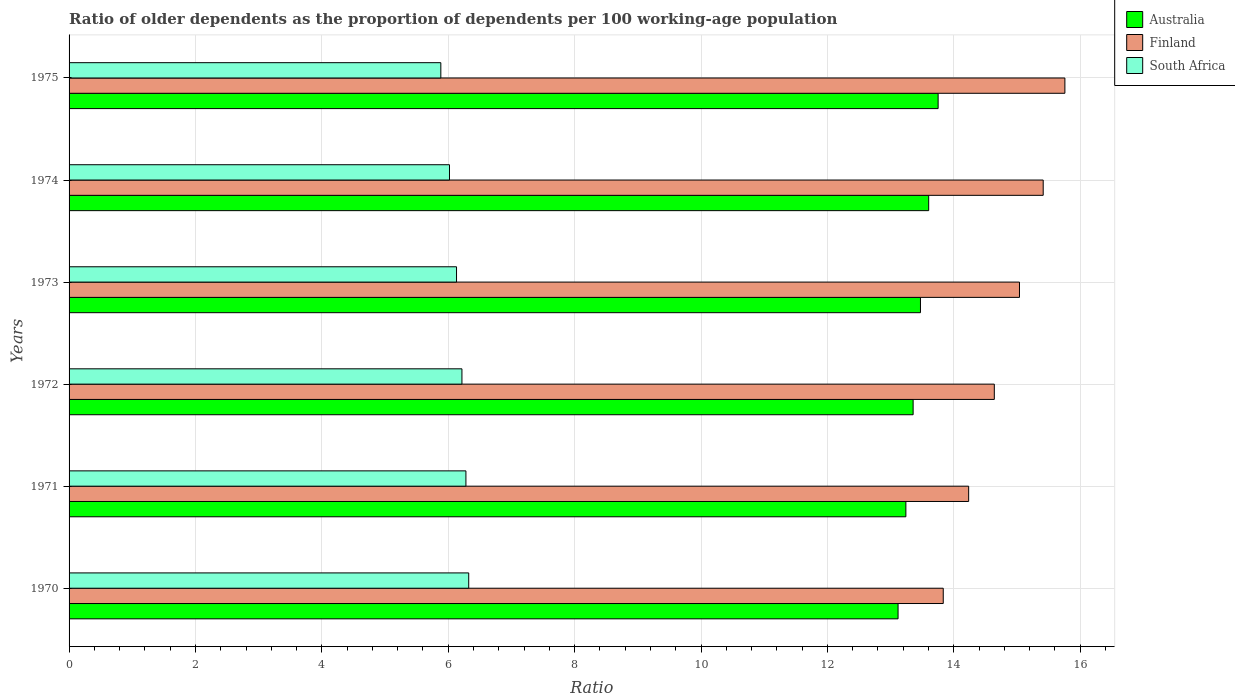How many groups of bars are there?
Provide a succinct answer. 6. Are the number of bars per tick equal to the number of legend labels?
Offer a very short reply. Yes. How many bars are there on the 3rd tick from the top?
Provide a succinct answer. 3. What is the label of the 6th group of bars from the top?
Provide a short and direct response. 1970. In how many cases, is the number of bars for a given year not equal to the number of legend labels?
Your response must be concise. 0. What is the age dependency ratio(old) in Finland in 1972?
Your answer should be very brief. 14.64. Across all years, what is the maximum age dependency ratio(old) in Finland?
Your answer should be compact. 15.76. Across all years, what is the minimum age dependency ratio(old) in Australia?
Offer a terse response. 13.12. In which year was the age dependency ratio(old) in Australia maximum?
Give a very brief answer. 1975. What is the total age dependency ratio(old) in Australia in the graph?
Make the answer very short. 80.54. What is the difference between the age dependency ratio(old) in Finland in 1970 and that in 1971?
Offer a terse response. -0.4. What is the difference between the age dependency ratio(old) in Finland in 1970 and the age dependency ratio(old) in Australia in 1974?
Ensure brevity in your answer.  0.23. What is the average age dependency ratio(old) in Australia per year?
Provide a short and direct response. 13.42. In the year 1973, what is the difference between the age dependency ratio(old) in Australia and age dependency ratio(old) in South Africa?
Provide a short and direct response. 7.34. In how many years, is the age dependency ratio(old) in Australia greater than 13.2 ?
Provide a short and direct response. 5. What is the ratio of the age dependency ratio(old) in Finland in 1970 to that in 1975?
Provide a succinct answer. 0.88. Is the difference between the age dependency ratio(old) in Australia in 1972 and 1973 greater than the difference between the age dependency ratio(old) in South Africa in 1972 and 1973?
Offer a very short reply. No. What is the difference between the highest and the second highest age dependency ratio(old) in South Africa?
Give a very brief answer. 0.04. What is the difference between the highest and the lowest age dependency ratio(old) in South Africa?
Provide a short and direct response. 0.44. In how many years, is the age dependency ratio(old) in South Africa greater than the average age dependency ratio(old) in South Africa taken over all years?
Ensure brevity in your answer.  3. What does the 3rd bar from the bottom in 1974 represents?
Provide a succinct answer. South Africa. Is it the case that in every year, the sum of the age dependency ratio(old) in South Africa and age dependency ratio(old) in Australia is greater than the age dependency ratio(old) in Finland?
Provide a short and direct response. Yes. Are the values on the major ticks of X-axis written in scientific E-notation?
Give a very brief answer. No. Does the graph contain any zero values?
Make the answer very short. No. Where does the legend appear in the graph?
Your answer should be very brief. Top right. What is the title of the graph?
Offer a very short reply. Ratio of older dependents as the proportion of dependents per 100 working-age population. What is the label or title of the X-axis?
Make the answer very short. Ratio. What is the Ratio of Australia in 1970?
Your answer should be very brief. 13.12. What is the Ratio of Finland in 1970?
Offer a terse response. 13.83. What is the Ratio in South Africa in 1970?
Your answer should be compact. 6.32. What is the Ratio of Australia in 1971?
Ensure brevity in your answer.  13.24. What is the Ratio of Finland in 1971?
Offer a terse response. 14.23. What is the Ratio in South Africa in 1971?
Offer a terse response. 6.28. What is the Ratio in Australia in 1972?
Give a very brief answer. 13.36. What is the Ratio in Finland in 1972?
Provide a short and direct response. 14.64. What is the Ratio of South Africa in 1972?
Your answer should be compact. 6.22. What is the Ratio in Australia in 1973?
Offer a terse response. 13.47. What is the Ratio in Finland in 1973?
Offer a very short reply. 15.04. What is the Ratio of South Africa in 1973?
Your answer should be very brief. 6.13. What is the Ratio in Australia in 1974?
Your answer should be very brief. 13.6. What is the Ratio of Finland in 1974?
Ensure brevity in your answer.  15.41. What is the Ratio in South Africa in 1974?
Offer a very short reply. 6.02. What is the Ratio of Australia in 1975?
Ensure brevity in your answer.  13.75. What is the Ratio of Finland in 1975?
Give a very brief answer. 15.76. What is the Ratio in South Africa in 1975?
Offer a very short reply. 5.88. Across all years, what is the maximum Ratio of Australia?
Your answer should be compact. 13.75. Across all years, what is the maximum Ratio in Finland?
Make the answer very short. 15.76. Across all years, what is the maximum Ratio of South Africa?
Provide a short and direct response. 6.32. Across all years, what is the minimum Ratio in Australia?
Ensure brevity in your answer.  13.12. Across all years, what is the minimum Ratio of Finland?
Offer a terse response. 13.83. Across all years, what is the minimum Ratio in South Africa?
Your answer should be compact. 5.88. What is the total Ratio of Australia in the graph?
Your answer should be compact. 80.54. What is the total Ratio in Finland in the graph?
Ensure brevity in your answer.  88.92. What is the total Ratio in South Africa in the graph?
Your answer should be very brief. 36.85. What is the difference between the Ratio of Australia in 1970 and that in 1971?
Give a very brief answer. -0.12. What is the difference between the Ratio of Finland in 1970 and that in 1971?
Provide a short and direct response. -0.4. What is the difference between the Ratio in South Africa in 1970 and that in 1971?
Provide a short and direct response. 0.04. What is the difference between the Ratio in Australia in 1970 and that in 1972?
Give a very brief answer. -0.24. What is the difference between the Ratio in Finland in 1970 and that in 1972?
Give a very brief answer. -0.81. What is the difference between the Ratio in South Africa in 1970 and that in 1972?
Offer a very short reply. 0.11. What is the difference between the Ratio in Australia in 1970 and that in 1973?
Ensure brevity in your answer.  -0.35. What is the difference between the Ratio in Finland in 1970 and that in 1973?
Give a very brief answer. -1.21. What is the difference between the Ratio in South Africa in 1970 and that in 1973?
Give a very brief answer. 0.19. What is the difference between the Ratio of Australia in 1970 and that in 1974?
Provide a short and direct response. -0.48. What is the difference between the Ratio of Finland in 1970 and that in 1974?
Your answer should be very brief. -1.58. What is the difference between the Ratio in South Africa in 1970 and that in 1974?
Provide a short and direct response. 0.3. What is the difference between the Ratio of Australia in 1970 and that in 1975?
Make the answer very short. -0.63. What is the difference between the Ratio in Finland in 1970 and that in 1975?
Offer a terse response. -1.92. What is the difference between the Ratio in South Africa in 1970 and that in 1975?
Offer a terse response. 0.44. What is the difference between the Ratio in Australia in 1971 and that in 1972?
Make the answer very short. -0.11. What is the difference between the Ratio of Finland in 1971 and that in 1972?
Keep it short and to the point. -0.41. What is the difference between the Ratio of South Africa in 1971 and that in 1972?
Keep it short and to the point. 0.06. What is the difference between the Ratio of Australia in 1971 and that in 1973?
Make the answer very short. -0.23. What is the difference between the Ratio of Finland in 1971 and that in 1973?
Offer a very short reply. -0.8. What is the difference between the Ratio in South Africa in 1971 and that in 1973?
Your answer should be very brief. 0.15. What is the difference between the Ratio of Australia in 1971 and that in 1974?
Offer a very short reply. -0.36. What is the difference between the Ratio of Finland in 1971 and that in 1974?
Your response must be concise. -1.18. What is the difference between the Ratio in South Africa in 1971 and that in 1974?
Your answer should be compact. 0.26. What is the difference between the Ratio in Australia in 1971 and that in 1975?
Your answer should be compact. -0.51. What is the difference between the Ratio in Finland in 1971 and that in 1975?
Your answer should be very brief. -1.52. What is the difference between the Ratio of South Africa in 1971 and that in 1975?
Provide a short and direct response. 0.4. What is the difference between the Ratio of Australia in 1972 and that in 1973?
Offer a very short reply. -0.12. What is the difference between the Ratio of Finland in 1972 and that in 1973?
Keep it short and to the point. -0.4. What is the difference between the Ratio in South Africa in 1972 and that in 1973?
Your answer should be very brief. 0.09. What is the difference between the Ratio of Australia in 1972 and that in 1974?
Make the answer very short. -0.25. What is the difference between the Ratio of Finland in 1972 and that in 1974?
Your answer should be very brief. -0.77. What is the difference between the Ratio in South Africa in 1972 and that in 1974?
Offer a very short reply. 0.2. What is the difference between the Ratio of Australia in 1972 and that in 1975?
Your answer should be very brief. -0.4. What is the difference between the Ratio in Finland in 1972 and that in 1975?
Your answer should be compact. -1.12. What is the difference between the Ratio in South Africa in 1972 and that in 1975?
Your response must be concise. 0.33. What is the difference between the Ratio in Australia in 1973 and that in 1974?
Your answer should be very brief. -0.13. What is the difference between the Ratio in Finland in 1973 and that in 1974?
Your answer should be very brief. -0.38. What is the difference between the Ratio in South Africa in 1973 and that in 1974?
Keep it short and to the point. 0.11. What is the difference between the Ratio of Australia in 1973 and that in 1975?
Offer a terse response. -0.28. What is the difference between the Ratio of Finland in 1973 and that in 1975?
Provide a short and direct response. -0.72. What is the difference between the Ratio in South Africa in 1973 and that in 1975?
Ensure brevity in your answer.  0.25. What is the difference between the Ratio of Australia in 1974 and that in 1975?
Your answer should be very brief. -0.15. What is the difference between the Ratio in Finland in 1974 and that in 1975?
Offer a terse response. -0.34. What is the difference between the Ratio of South Africa in 1974 and that in 1975?
Offer a very short reply. 0.14. What is the difference between the Ratio in Australia in 1970 and the Ratio in Finland in 1971?
Provide a succinct answer. -1.12. What is the difference between the Ratio of Australia in 1970 and the Ratio of South Africa in 1971?
Ensure brevity in your answer.  6.84. What is the difference between the Ratio of Finland in 1970 and the Ratio of South Africa in 1971?
Give a very brief answer. 7.55. What is the difference between the Ratio in Australia in 1970 and the Ratio in Finland in 1972?
Ensure brevity in your answer.  -1.52. What is the difference between the Ratio of Australia in 1970 and the Ratio of South Africa in 1972?
Provide a succinct answer. 6.9. What is the difference between the Ratio in Finland in 1970 and the Ratio in South Africa in 1972?
Your response must be concise. 7.62. What is the difference between the Ratio of Australia in 1970 and the Ratio of Finland in 1973?
Offer a very short reply. -1.92. What is the difference between the Ratio of Australia in 1970 and the Ratio of South Africa in 1973?
Make the answer very short. 6.99. What is the difference between the Ratio in Finland in 1970 and the Ratio in South Africa in 1973?
Provide a short and direct response. 7.7. What is the difference between the Ratio in Australia in 1970 and the Ratio in Finland in 1974?
Provide a succinct answer. -2.3. What is the difference between the Ratio in Australia in 1970 and the Ratio in South Africa in 1974?
Keep it short and to the point. 7.1. What is the difference between the Ratio of Finland in 1970 and the Ratio of South Africa in 1974?
Your answer should be compact. 7.81. What is the difference between the Ratio of Australia in 1970 and the Ratio of Finland in 1975?
Ensure brevity in your answer.  -2.64. What is the difference between the Ratio of Australia in 1970 and the Ratio of South Africa in 1975?
Your answer should be compact. 7.24. What is the difference between the Ratio in Finland in 1970 and the Ratio in South Africa in 1975?
Keep it short and to the point. 7.95. What is the difference between the Ratio of Australia in 1971 and the Ratio of Finland in 1972?
Your response must be concise. -1.4. What is the difference between the Ratio of Australia in 1971 and the Ratio of South Africa in 1972?
Offer a terse response. 7.02. What is the difference between the Ratio of Finland in 1971 and the Ratio of South Africa in 1972?
Provide a succinct answer. 8.02. What is the difference between the Ratio in Australia in 1971 and the Ratio in Finland in 1973?
Ensure brevity in your answer.  -1.8. What is the difference between the Ratio of Australia in 1971 and the Ratio of South Africa in 1973?
Provide a short and direct response. 7.11. What is the difference between the Ratio in Finland in 1971 and the Ratio in South Africa in 1973?
Provide a succinct answer. 8.1. What is the difference between the Ratio in Australia in 1971 and the Ratio in Finland in 1974?
Ensure brevity in your answer.  -2.17. What is the difference between the Ratio of Australia in 1971 and the Ratio of South Africa in 1974?
Provide a succinct answer. 7.22. What is the difference between the Ratio of Finland in 1971 and the Ratio of South Africa in 1974?
Provide a succinct answer. 8.21. What is the difference between the Ratio of Australia in 1971 and the Ratio of Finland in 1975?
Your response must be concise. -2.52. What is the difference between the Ratio in Australia in 1971 and the Ratio in South Africa in 1975?
Offer a terse response. 7.36. What is the difference between the Ratio of Finland in 1971 and the Ratio of South Africa in 1975?
Give a very brief answer. 8.35. What is the difference between the Ratio of Australia in 1972 and the Ratio of Finland in 1973?
Give a very brief answer. -1.68. What is the difference between the Ratio in Australia in 1972 and the Ratio in South Africa in 1973?
Offer a terse response. 7.22. What is the difference between the Ratio in Finland in 1972 and the Ratio in South Africa in 1973?
Ensure brevity in your answer.  8.51. What is the difference between the Ratio of Australia in 1972 and the Ratio of Finland in 1974?
Your response must be concise. -2.06. What is the difference between the Ratio in Australia in 1972 and the Ratio in South Africa in 1974?
Your answer should be compact. 7.34. What is the difference between the Ratio in Finland in 1972 and the Ratio in South Africa in 1974?
Your answer should be compact. 8.62. What is the difference between the Ratio of Australia in 1972 and the Ratio of Finland in 1975?
Ensure brevity in your answer.  -2.4. What is the difference between the Ratio in Australia in 1972 and the Ratio in South Africa in 1975?
Give a very brief answer. 7.47. What is the difference between the Ratio in Finland in 1972 and the Ratio in South Africa in 1975?
Your answer should be compact. 8.76. What is the difference between the Ratio in Australia in 1973 and the Ratio in Finland in 1974?
Ensure brevity in your answer.  -1.94. What is the difference between the Ratio in Australia in 1973 and the Ratio in South Africa in 1974?
Make the answer very short. 7.45. What is the difference between the Ratio in Finland in 1973 and the Ratio in South Africa in 1974?
Your answer should be very brief. 9.02. What is the difference between the Ratio in Australia in 1973 and the Ratio in Finland in 1975?
Provide a short and direct response. -2.29. What is the difference between the Ratio in Australia in 1973 and the Ratio in South Africa in 1975?
Give a very brief answer. 7.59. What is the difference between the Ratio of Finland in 1973 and the Ratio of South Africa in 1975?
Your answer should be very brief. 9.16. What is the difference between the Ratio in Australia in 1974 and the Ratio in Finland in 1975?
Provide a short and direct response. -2.16. What is the difference between the Ratio in Australia in 1974 and the Ratio in South Africa in 1975?
Ensure brevity in your answer.  7.72. What is the difference between the Ratio in Finland in 1974 and the Ratio in South Africa in 1975?
Provide a short and direct response. 9.53. What is the average Ratio in Australia per year?
Give a very brief answer. 13.42. What is the average Ratio in Finland per year?
Your answer should be very brief. 14.82. What is the average Ratio of South Africa per year?
Offer a very short reply. 6.14. In the year 1970, what is the difference between the Ratio in Australia and Ratio in Finland?
Ensure brevity in your answer.  -0.71. In the year 1970, what is the difference between the Ratio in Australia and Ratio in South Africa?
Your response must be concise. 6.79. In the year 1970, what is the difference between the Ratio of Finland and Ratio of South Africa?
Provide a succinct answer. 7.51. In the year 1971, what is the difference between the Ratio in Australia and Ratio in Finland?
Offer a terse response. -0.99. In the year 1971, what is the difference between the Ratio of Australia and Ratio of South Africa?
Provide a succinct answer. 6.96. In the year 1971, what is the difference between the Ratio in Finland and Ratio in South Africa?
Make the answer very short. 7.95. In the year 1972, what is the difference between the Ratio of Australia and Ratio of Finland?
Keep it short and to the point. -1.28. In the year 1972, what is the difference between the Ratio in Australia and Ratio in South Africa?
Provide a succinct answer. 7.14. In the year 1972, what is the difference between the Ratio of Finland and Ratio of South Africa?
Your answer should be compact. 8.42. In the year 1973, what is the difference between the Ratio of Australia and Ratio of Finland?
Offer a very short reply. -1.57. In the year 1973, what is the difference between the Ratio in Australia and Ratio in South Africa?
Make the answer very short. 7.34. In the year 1973, what is the difference between the Ratio in Finland and Ratio in South Africa?
Your response must be concise. 8.91. In the year 1974, what is the difference between the Ratio in Australia and Ratio in Finland?
Ensure brevity in your answer.  -1.81. In the year 1974, what is the difference between the Ratio of Australia and Ratio of South Africa?
Keep it short and to the point. 7.58. In the year 1974, what is the difference between the Ratio of Finland and Ratio of South Africa?
Provide a succinct answer. 9.39. In the year 1975, what is the difference between the Ratio in Australia and Ratio in Finland?
Offer a terse response. -2.01. In the year 1975, what is the difference between the Ratio in Australia and Ratio in South Africa?
Provide a short and direct response. 7.87. In the year 1975, what is the difference between the Ratio of Finland and Ratio of South Africa?
Ensure brevity in your answer.  9.88. What is the ratio of the Ratio of Finland in 1970 to that in 1971?
Ensure brevity in your answer.  0.97. What is the ratio of the Ratio of South Africa in 1970 to that in 1971?
Ensure brevity in your answer.  1.01. What is the ratio of the Ratio of Australia in 1970 to that in 1972?
Make the answer very short. 0.98. What is the ratio of the Ratio of Finland in 1970 to that in 1972?
Give a very brief answer. 0.94. What is the ratio of the Ratio of South Africa in 1970 to that in 1972?
Offer a terse response. 1.02. What is the ratio of the Ratio of Australia in 1970 to that in 1973?
Ensure brevity in your answer.  0.97. What is the ratio of the Ratio of Finland in 1970 to that in 1973?
Keep it short and to the point. 0.92. What is the ratio of the Ratio of South Africa in 1970 to that in 1973?
Give a very brief answer. 1.03. What is the ratio of the Ratio in Australia in 1970 to that in 1974?
Your answer should be compact. 0.96. What is the ratio of the Ratio of Finland in 1970 to that in 1974?
Provide a short and direct response. 0.9. What is the ratio of the Ratio in South Africa in 1970 to that in 1974?
Keep it short and to the point. 1.05. What is the ratio of the Ratio in Australia in 1970 to that in 1975?
Make the answer very short. 0.95. What is the ratio of the Ratio in Finland in 1970 to that in 1975?
Your answer should be compact. 0.88. What is the ratio of the Ratio in South Africa in 1970 to that in 1975?
Provide a succinct answer. 1.07. What is the ratio of the Ratio of Finland in 1971 to that in 1972?
Keep it short and to the point. 0.97. What is the ratio of the Ratio of South Africa in 1971 to that in 1972?
Offer a terse response. 1.01. What is the ratio of the Ratio in Australia in 1971 to that in 1973?
Keep it short and to the point. 0.98. What is the ratio of the Ratio in Finland in 1971 to that in 1973?
Make the answer very short. 0.95. What is the ratio of the Ratio in South Africa in 1971 to that in 1973?
Your answer should be very brief. 1.02. What is the ratio of the Ratio in Australia in 1971 to that in 1974?
Your answer should be very brief. 0.97. What is the ratio of the Ratio in Finland in 1971 to that in 1974?
Offer a very short reply. 0.92. What is the ratio of the Ratio in South Africa in 1971 to that in 1974?
Your answer should be very brief. 1.04. What is the ratio of the Ratio of Australia in 1971 to that in 1975?
Your answer should be compact. 0.96. What is the ratio of the Ratio in Finland in 1971 to that in 1975?
Ensure brevity in your answer.  0.9. What is the ratio of the Ratio in South Africa in 1971 to that in 1975?
Offer a terse response. 1.07. What is the ratio of the Ratio of Australia in 1972 to that in 1973?
Your answer should be compact. 0.99. What is the ratio of the Ratio in Finland in 1972 to that in 1973?
Provide a short and direct response. 0.97. What is the ratio of the Ratio of South Africa in 1972 to that in 1973?
Keep it short and to the point. 1.01. What is the ratio of the Ratio of Australia in 1972 to that in 1974?
Give a very brief answer. 0.98. What is the ratio of the Ratio in Finland in 1972 to that in 1974?
Give a very brief answer. 0.95. What is the ratio of the Ratio of South Africa in 1972 to that in 1974?
Offer a terse response. 1.03. What is the ratio of the Ratio in Australia in 1972 to that in 1975?
Your response must be concise. 0.97. What is the ratio of the Ratio in Finland in 1972 to that in 1975?
Your answer should be very brief. 0.93. What is the ratio of the Ratio in South Africa in 1972 to that in 1975?
Give a very brief answer. 1.06. What is the ratio of the Ratio in Finland in 1973 to that in 1974?
Make the answer very short. 0.98. What is the ratio of the Ratio of South Africa in 1973 to that in 1974?
Make the answer very short. 1.02. What is the ratio of the Ratio in Australia in 1973 to that in 1975?
Your response must be concise. 0.98. What is the ratio of the Ratio in Finland in 1973 to that in 1975?
Offer a very short reply. 0.95. What is the ratio of the Ratio of South Africa in 1973 to that in 1975?
Ensure brevity in your answer.  1.04. What is the ratio of the Ratio in Australia in 1974 to that in 1975?
Your answer should be compact. 0.99. What is the ratio of the Ratio in Finland in 1974 to that in 1975?
Offer a very short reply. 0.98. What is the ratio of the Ratio in South Africa in 1974 to that in 1975?
Your answer should be very brief. 1.02. What is the difference between the highest and the second highest Ratio in Australia?
Your response must be concise. 0.15. What is the difference between the highest and the second highest Ratio of Finland?
Your response must be concise. 0.34. What is the difference between the highest and the second highest Ratio of South Africa?
Provide a succinct answer. 0.04. What is the difference between the highest and the lowest Ratio in Australia?
Your answer should be compact. 0.63. What is the difference between the highest and the lowest Ratio of Finland?
Keep it short and to the point. 1.92. What is the difference between the highest and the lowest Ratio of South Africa?
Ensure brevity in your answer.  0.44. 